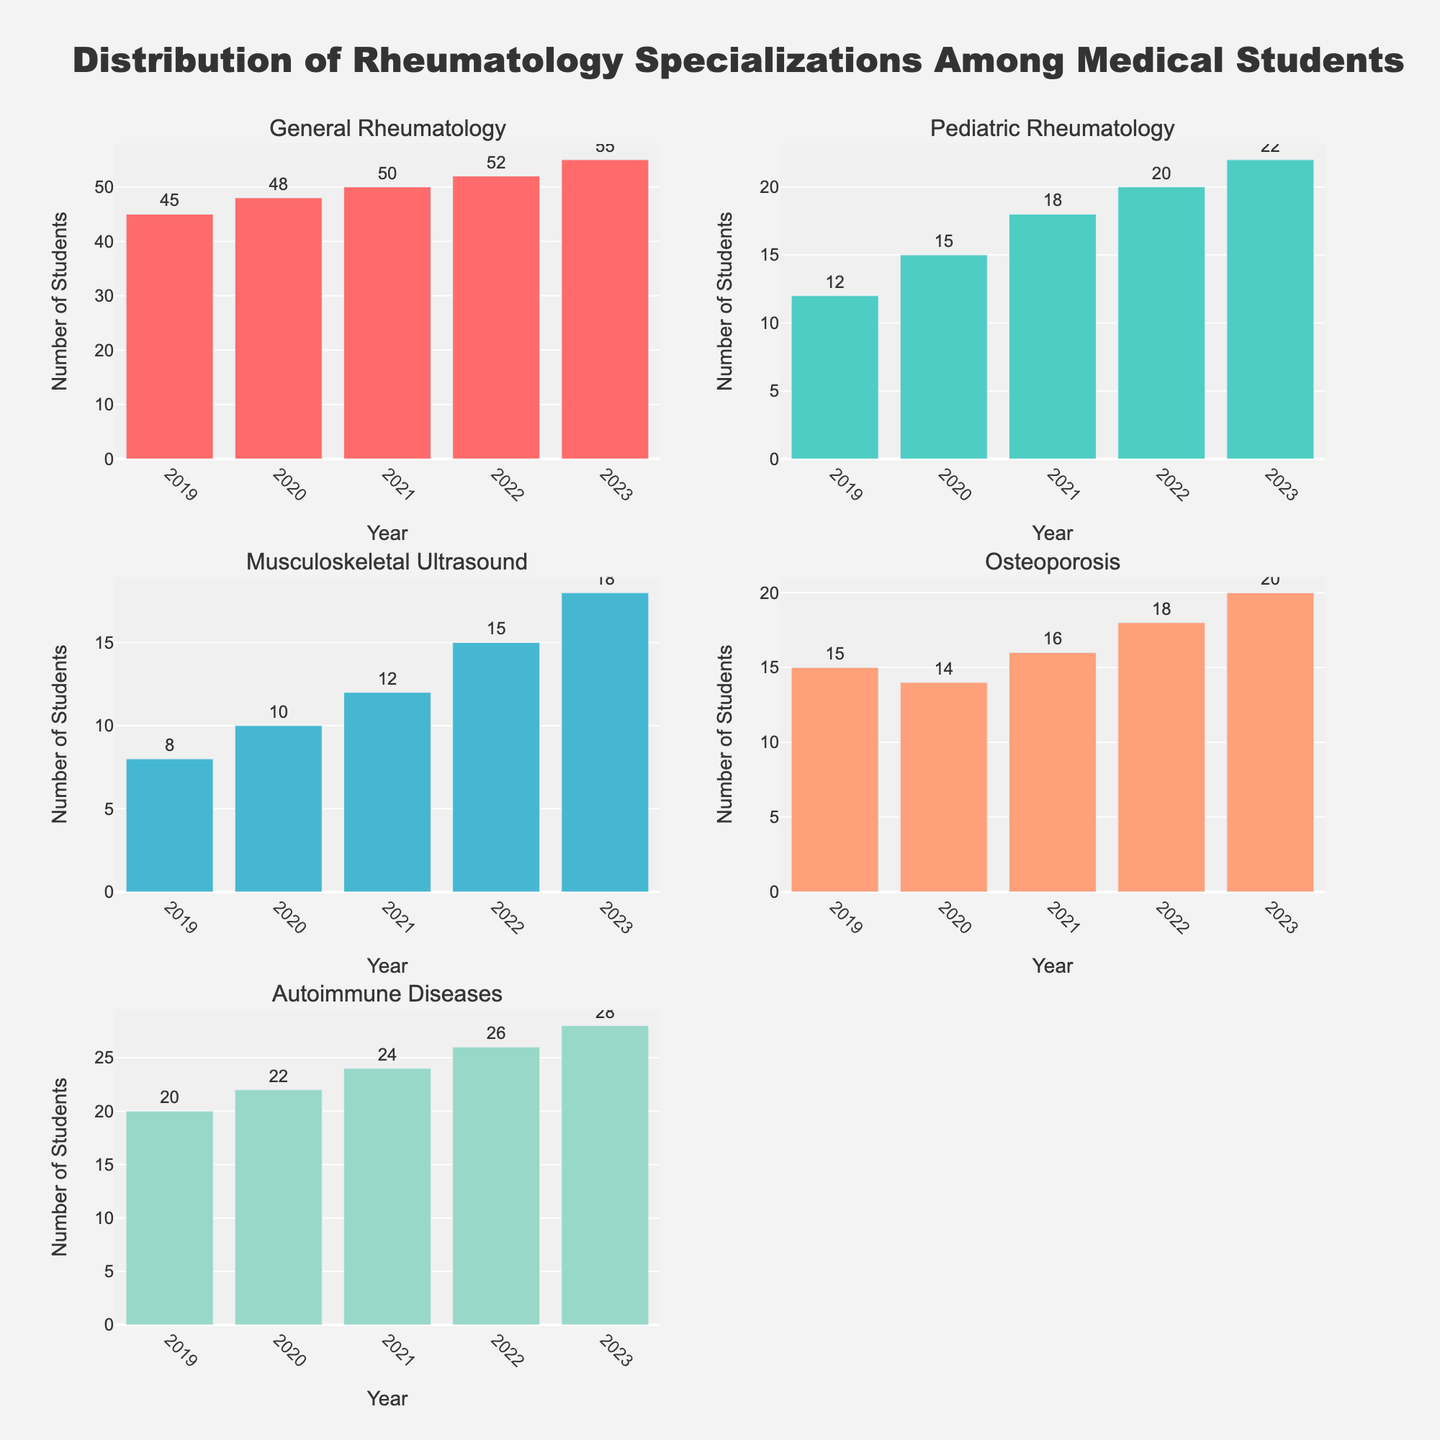Which specialization had the highest number of students in 2023? Examine the bar representing the year 2023 for each subplot. The longest bar represents General Rheumatology with 55 students.
Answer: General Rheumatology What is the trend of Pediatric Rheumatology from 2019 to 2023? Observe the bars in the Pediatric Rheumatology subplot for each year from 2019 to 2023. The bars show an increasing trend, from 12 in 2019 to 22 in 2023.
Answer: Increasing How many students chose Musculoskeletal Ultrasound in 2021? Refer to the bar for the year 2021 in the Musculoskeletal Ultrasound subplot. The bar label indicates 12 students.
Answer: 12 Which year had the smallest number of students interested in Osteoporosis? Compare the bars for all years in the Osteoporosis subplot. The shortest bar is for 2020, showing 14 students.
Answer: 2020 How did the interest in Autoimmune Diseases change from 2019 to 2022? Look at the bars for Autoimmune Diseases from 2019 to 2022. The bars show an increase from 20 students in 2019 to 26 students in 2022.
Answer: Increased By how much did the number of students interested in Musculoskeletal Ultrasound increase from 2019 to 2023? Subtract the number of students in 2019 from the number in 2023 (18 - 8). The increase is 10 students.
Answer: 10 What is the total number of students who chose any specialization in 2020? Sum the values for all specializations in 2020: 48 + 15 + 10 + 14 + 22 = 109.
Answer: 109 Which specialization saw the highest absolute increase in students from 2019 to 2023? Calculate the difference for each specialization: 
- General Rheumatology: 55 - 45 = 10 
- Pediatric Rheumatology: 22 - 12 = 10 
- Musculoskeletal Ultrasound: 18 - 8 = 10 
- Osteoporosis: 20 - 15 = 5 
- Autoimmune Diseases: 28 - 20 = 8 
Three specializations tie for the highest increase: General Rheumatology, Pediatric Rheumatology, Musculoskeletal Ultrasound.
Answer: General Rheumatology, Pediatric Rheumatology, Musculoskeletal Ultrasound Which specialization had the least number of students interested in 2021? Compare the bars for all specializations in 2021. The shortest bar is for Musculoskeletal Ultrasound with 12 students.
Answer: Musculoskeletal Ultrasound 